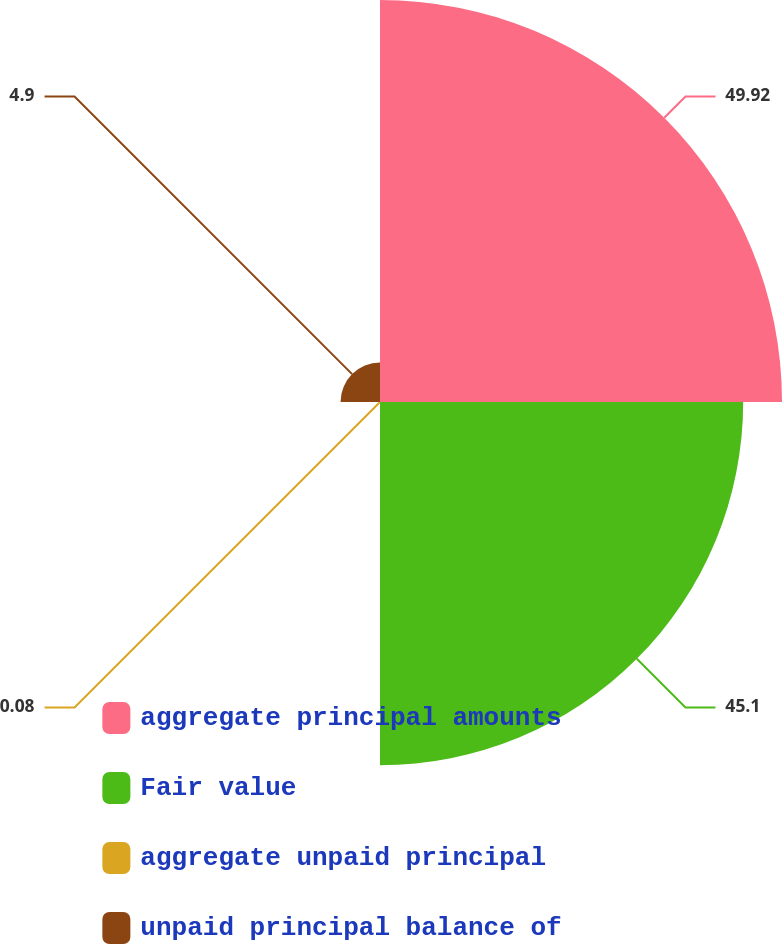Convert chart to OTSL. <chart><loc_0><loc_0><loc_500><loc_500><pie_chart><fcel>aggregate principal amounts<fcel>Fair value<fcel>aggregate unpaid principal<fcel>unpaid principal balance of<nl><fcel>49.92%<fcel>45.1%<fcel>0.08%<fcel>4.9%<nl></chart> 